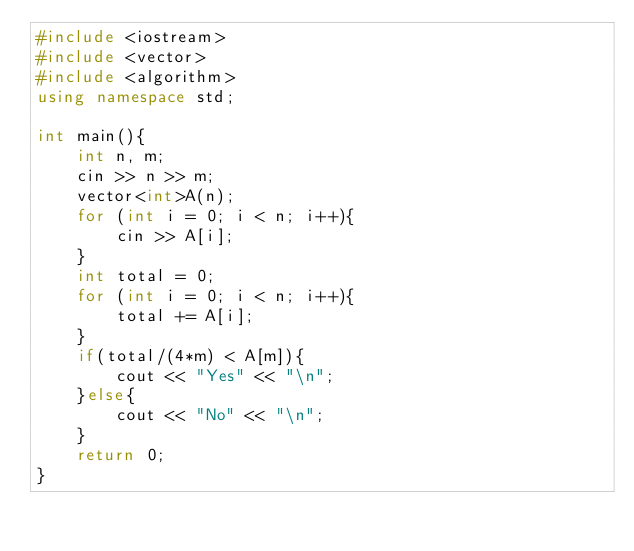<code> <loc_0><loc_0><loc_500><loc_500><_C++_>#include <iostream>
#include <vector>
#include <algorithm>
using namespace std;

int main(){
    int n, m;
    cin >> n >> m;
    vector<int>A(n);
    for (int i = 0; i < n; i++){
        cin >> A[i];
    }
    int total = 0;
    for (int i = 0; i < n; i++){
        total += A[i];
    }
    if(total/(4*m) < A[m]){
        cout << "Yes" << "\n";
    }else{
        cout << "No" << "\n";
    }
    return 0;
}</code> 